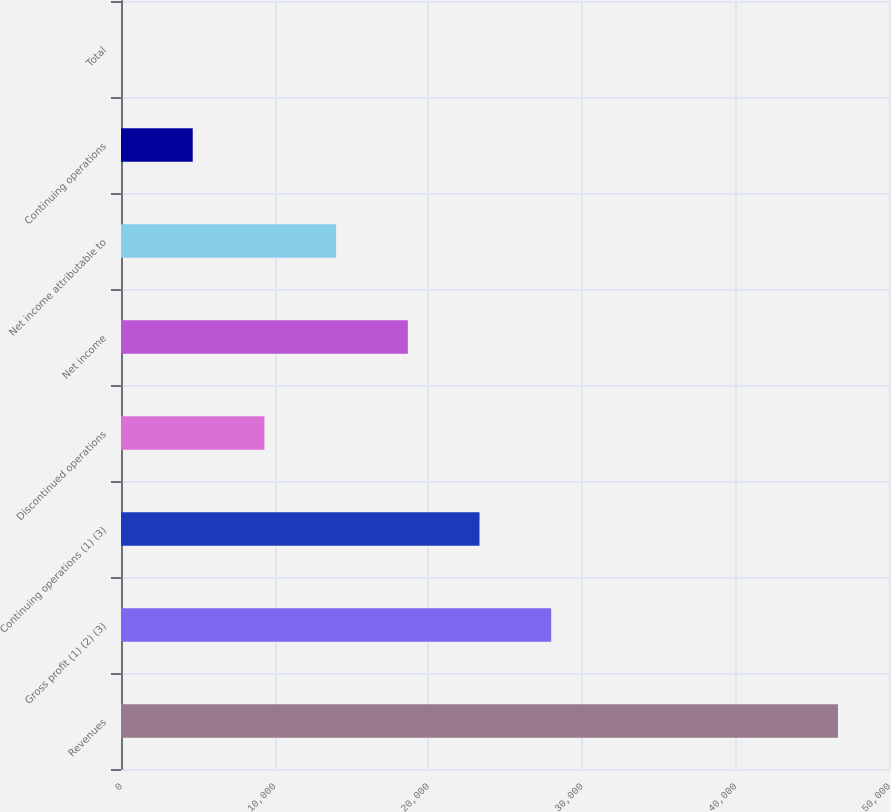Convert chart. <chart><loc_0><loc_0><loc_500><loc_500><bar_chart><fcel>Revenues<fcel>Gross profit (1) (2) (3)<fcel>Continuing operations (1) (3)<fcel>Discontinued operations<fcel>Net income<fcel>Net income attributable to<fcel>Continuing operations<fcel>Total<nl><fcel>46678<fcel>28007.5<fcel>23339.9<fcel>9337.1<fcel>18672.3<fcel>14004.7<fcel>4669.49<fcel>1.88<nl></chart> 